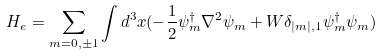<formula> <loc_0><loc_0><loc_500><loc_500>H _ { e } = \sum _ { m = 0 , \pm 1 } \int d ^ { 3 } x ( - \frac { 1 } { 2 } \psi _ { m } ^ { \dagger } \nabla ^ { 2 } \psi _ { m } + W \delta _ { | m | , 1 } \psi _ { m } ^ { \dagger } \psi _ { m } )</formula> 